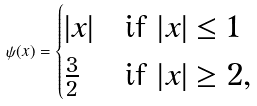<formula> <loc_0><loc_0><loc_500><loc_500>\psi ( x ) = \begin{cases} | x | & \text {if } | x | \leq 1 \\ \frac { 3 } { 2 } & \text {if } | x | \geq 2 , \end{cases}</formula> 